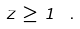Convert formula to latex. <formula><loc_0><loc_0><loc_500><loc_500>z \geq 1 \ .</formula> 